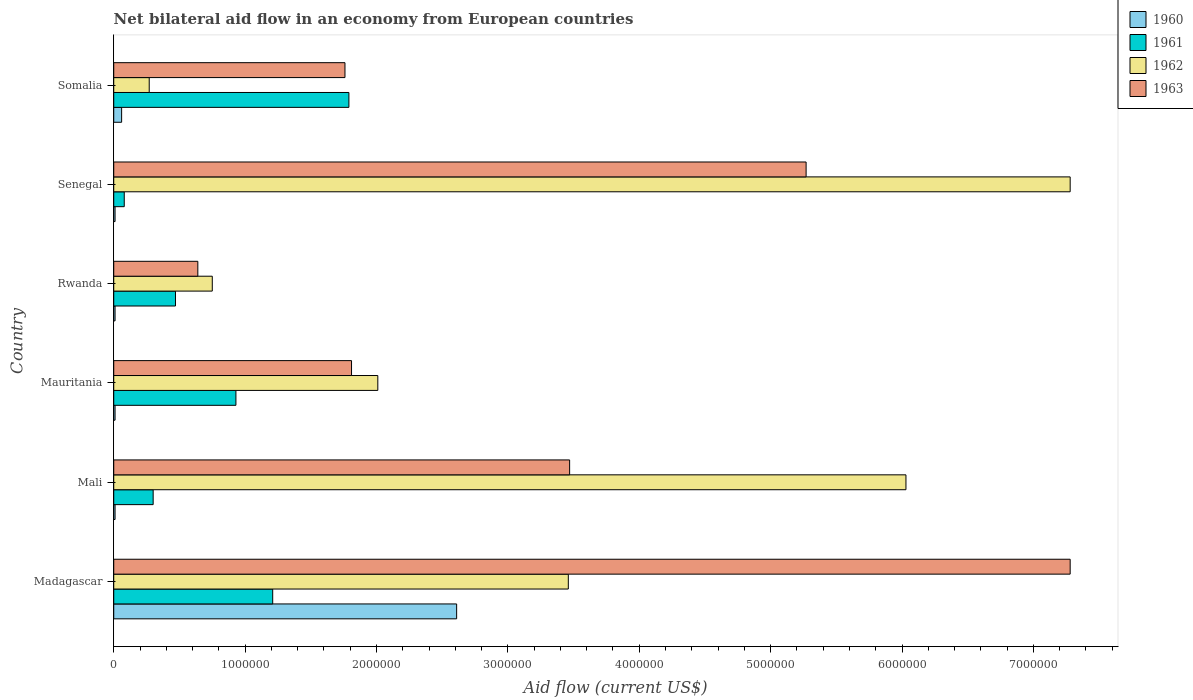How many groups of bars are there?
Provide a short and direct response. 6. Are the number of bars per tick equal to the number of legend labels?
Your response must be concise. Yes. How many bars are there on the 4th tick from the top?
Ensure brevity in your answer.  4. How many bars are there on the 3rd tick from the bottom?
Provide a succinct answer. 4. What is the label of the 1st group of bars from the top?
Your answer should be very brief. Somalia. What is the net bilateral aid flow in 1963 in Rwanda?
Keep it short and to the point. 6.40e+05. Across all countries, what is the maximum net bilateral aid flow in 1961?
Ensure brevity in your answer.  1.79e+06. Across all countries, what is the minimum net bilateral aid flow in 1961?
Provide a short and direct response. 8.00e+04. In which country was the net bilateral aid flow in 1963 maximum?
Your answer should be very brief. Madagascar. In which country was the net bilateral aid flow in 1962 minimum?
Give a very brief answer. Somalia. What is the total net bilateral aid flow in 1960 in the graph?
Offer a terse response. 2.71e+06. What is the difference between the net bilateral aid flow in 1961 in Mauritania and that in Senegal?
Your answer should be very brief. 8.50e+05. What is the average net bilateral aid flow in 1961 per country?
Ensure brevity in your answer.  7.97e+05. In how many countries, is the net bilateral aid flow in 1963 greater than 4400000 US$?
Provide a short and direct response. 2. What is the ratio of the net bilateral aid flow in 1960 in Madagascar to that in Mauritania?
Your response must be concise. 261. Is the net bilateral aid flow in 1963 in Mauritania less than that in Senegal?
Keep it short and to the point. Yes. Is the difference between the net bilateral aid flow in 1961 in Senegal and Somalia greater than the difference between the net bilateral aid flow in 1960 in Senegal and Somalia?
Offer a very short reply. No. What is the difference between the highest and the second highest net bilateral aid flow in 1961?
Provide a short and direct response. 5.80e+05. What is the difference between the highest and the lowest net bilateral aid flow in 1961?
Make the answer very short. 1.71e+06. Is the sum of the net bilateral aid flow in 1961 in Rwanda and Senegal greater than the maximum net bilateral aid flow in 1960 across all countries?
Keep it short and to the point. No. Is it the case that in every country, the sum of the net bilateral aid flow in 1963 and net bilateral aid flow in 1961 is greater than the sum of net bilateral aid flow in 1962 and net bilateral aid flow in 1960?
Give a very brief answer. Yes. What does the 3rd bar from the top in Madagascar represents?
Provide a short and direct response. 1961. What does the 1st bar from the bottom in Rwanda represents?
Your response must be concise. 1960. How many bars are there?
Make the answer very short. 24. What is the difference between two consecutive major ticks on the X-axis?
Your answer should be very brief. 1.00e+06. Are the values on the major ticks of X-axis written in scientific E-notation?
Offer a terse response. No. Does the graph contain grids?
Give a very brief answer. No. How many legend labels are there?
Give a very brief answer. 4. How are the legend labels stacked?
Ensure brevity in your answer.  Vertical. What is the title of the graph?
Keep it short and to the point. Net bilateral aid flow in an economy from European countries. What is the Aid flow (current US$) in 1960 in Madagascar?
Give a very brief answer. 2.61e+06. What is the Aid flow (current US$) of 1961 in Madagascar?
Keep it short and to the point. 1.21e+06. What is the Aid flow (current US$) in 1962 in Madagascar?
Make the answer very short. 3.46e+06. What is the Aid flow (current US$) in 1963 in Madagascar?
Your answer should be very brief. 7.28e+06. What is the Aid flow (current US$) of 1962 in Mali?
Ensure brevity in your answer.  6.03e+06. What is the Aid flow (current US$) in 1963 in Mali?
Provide a short and direct response. 3.47e+06. What is the Aid flow (current US$) in 1961 in Mauritania?
Your response must be concise. 9.30e+05. What is the Aid flow (current US$) in 1962 in Mauritania?
Give a very brief answer. 2.01e+06. What is the Aid flow (current US$) in 1963 in Mauritania?
Your response must be concise. 1.81e+06. What is the Aid flow (current US$) of 1962 in Rwanda?
Provide a succinct answer. 7.50e+05. What is the Aid flow (current US$) in 1963 in Rwanda?
Give a very brief answer. 6.40e+05. What is the Aid flow (current US$) of 1960 in Senegal?
Keep it short and to the point. 10000. What is the Aid flow (current US$) of 1962 in Senegal?
Give a very brief answer. 7.28e+06. What is the Aid flow (current US$) of 1963 in Senegal?
Make the answer very short. 5.27e+06. What is the Aid flow (current US$) in 1960 in Somalia?
Give a very brief answer. 6.00e+04. What is the Aid flow (current US$) in 1961 in Somalia?
Ensure brevity in your answer.  1.79e+06. What is the Aid flow (current US$) of 1962 in Somalia?
Your response must be concise. 2.70e+05. What is the Aid flow (current US$) of 1963 in Somalia?
Ensure brevity in your answer.  1.76e+06. Across all countries, what is the maximum Aid flow (current US$) of 1960?
Your answer should be very brief. 2.61e+06. Across all countries, what is the maximum Aid flow (current US$) in 1961?
Give a very brief answer. 1.79e+06. Across all countries, what is the maximum Aid flow (current US$) of 1962?
Provide a short and direct response. 7.28e+06. Across all countries, what is the maximum Aid flow (current US$) of 1963?
Give a very brief answer. 7.28e+06. Across all countries, what is the minimum Aid flow (current US$) in 1961?
Your answer should be very brief. 8.00e+04. Across all countries, what is the minimum Aid flow (current US$) of 1963?
Provide a short and direct response. 6.40e+05. What is the total Aid flow (current US$) of 1960 in the graph?
Provide a succinct answer. 2.71e+06. What is the total Aid flow (current US$) of 1961 in the graph?
Give a very brief answer. 4.78e+06. What is the total Aid flow (current US$) in 1962 in the graph?
Your answer should be very brief. 1.98e+07. What is the total Aid flow (current US$) in 1963 in the graph?
Provide a short and direct response. 2.02e+07. What is the difference between the Aid flow (current US$) in 1960 in Madagascar and that in Mali?
Give a very brief answer. 2.60e+06. What is the difference between the Aid flow (current US$) in 1961 in Madagascar and that in Mali?
Ensure brevity in your answer.  9.10e+05. What is the difference between the Aid flow (current US$) in 1962 in Madagascar and that in Mali?
Give a very brief answer. -2.57e+06. What is the difference between the Aid flow (current US$) in 1963 in Madagascar and that in Mali?
Your answer should be very brief. 3.81e+06. What is the difference between the Aid flow (current US$) of 1960 in Madagascar and that in Mauritania?
Your answer should be compact. 2.60e+06. What is the difference between the Aid flow (current US$) of 1961 in Madagascar and that in Mauritania?
Your answer should be very brief. 2.80e+05. What is the difference between the Aid flow (current US$) in 1962 in Madagascar and that in Mauritania?
Your answer should be very brief. 1.45e+06. What is the difference between the Aid flow (current US$) of 1963 in Madagascar and that in Mauritania?
Make the answer very short. 5.47e+06. What is the difference between the Aid flow (current US$) of 1960 in Madagascar and that in Rwanda?
Provide a short and direct response. 2.60e+06. What is the difference between the Aid flow (current US$) of 1961 in Madagascar and that in Rwanda?
Ensure brevity in your answer.  7.40e+05. What is the difference between the Aid flow (current US$) in 1962 in Madagascar and that in Rwanda?
Your answer should be very brief. 2.71e+06. What is the difference between the Aid flow (current US$) of 1963 in Madagascar and that in Rwanda?
Your answer should be very brief. 6.64e+06. What is the difference between the Aid flow (current US$) in 1960 in Madagascar and that in Senegal?
Offer a terse response. 2.60e+06. What is the difference between the Aid flow (current US$) in 1961 in Madagascar and that in Senegal?
Keep it short and to the point. 1.13e+06. What is the difference between the Aid flow (current US$) of 1962 in Madagascar and that in Senegal?
Your answer should be compact. -3.82e+06. What is the difference between the Aid flow (current US$) of 1963 in Madagascar and that in Senegal?
Provide a short and direct response. 2.01e+06. What is the difference between the Aid flow (current US$) of 1960 in Madagascar and that in Somalia?
Offer a terse response. 2.55e+06. What is the difference between the Aid flow (current US$) in 1961 in Madagascar and that in Somalia?
Give a very brief answer. -5.80e+05. What is the difference between the Aid flow (current US$) of 1962 in Madagascar and that in Somalia?
Keep it short and to the point. 3.19e+06. What is the difference between the Aid flow (current US$) in 1963 in Madagascar and that in Somalia?
Your answer should be very brief. 5.52e+06. What is the difference between the Aid flow (current US$) of 1960 in Mali and that in Mauritania?
Offer a terse response. 0. What is the difference between the Aid flow (current US$) in 1961 in Mali and that in Mauritania?
Offer a very short reply. -6.30e+05. What is the difference between the Aid flow (current US$) in 1962 in Mali and that in Mauritania?
Keep it short and to the point. 4.02e+06. What is the difference between the Aid flow (current US$) of 1963 in Mali and that in Mauritania?
Offer a very short reply. 1.66e+06. What is the difference between the Aid flow (current US$) of 1961 in Mali and that in Rwanda?
Ensure brevity in your answer.  -1.70e+05. What is the difference between the Aid flow (current US$) in 1962 in Mali and that in Rwanda?
Your response must be concise. 5.28e+06. What is the difference between the Aid flow (current US$) in 1963 in Mali and that in Rwanda?
Make the answer very short. 2.83e+06. What is the difference between the Aid flow (current US$) in 1960 in Mali and that in Senegal?
Your answer should be very brief. 0. What is the difference between the Aid flow (current US$) of 1962 in Mali and that in Senegal?
Ensure brevity in your answer.  -1.25e+06. What is the difference between the Aid flow (current US$) in 1963 in Mali and that in Senegal?
Provide a short and direct response. -1.80e+06. What is the difference between the Aid flow (current US$) of 1960 in Mali and that in Somalia?
Provide a short and direct response. -5.00e+04. What is the difference between the Aid flow (current US$) of 1961 in Mali and that in Somalia?
Keep it short and to the point. -1.49e+06. What is the difference between the Aid flow (current US$) of 1962 in Mali and that in Somalia?
Ensure brevity in your answer.  5.76e+06. What is the difference between the Aid flow (current US$) in 1963 in Mali and that in Somalia?
Make the answer very short. 1.71e+06. What is the difference between the Aid flow (current US$) of 1961 in Mauritania and that in Rwanda?
Make the answer very short. 4.60e+05. What is the difference between the Aid flow (current US$) in 1962 in Mauritania and that in Rwanda?
Make the answer very short. 1.26e+06. What is the difference between the Aid flow (current US$) in 1963 in Mauritania and that in Rwanda?
Your response must be concise. 1.17e+06. What is the difference between the Aid flow (current US$) of 1960 in Mauritania and that in Senegal?
Your response must be concise. 0. What is the difference between the Aid flow (current US$) in 1961 in Mauritania and that in Senegal?
Ensure brevity in your answer.  8.50e+05. What is the difference between the Aid flow (current US$) of 1962 in Mauritania and that in Senegal?
Keep it short and to the point. -5.27e+06. What is the difference between the Aid flow (current US$) of 1963 in Mauritania and that in Senegal?
Make the answer very short. -3.46e+06. What is the difference between the Aid flow (current US$) of 1960 in Mauritania and that in Somalia?
Your answer should be very brief. -5.00e+04. What is the difference between the Aid flow (current US$) of 1961 in Mauritania and that in Somalia?
Your response must be concise. -8.60e+05. What is the difference between the Aid flow (current US$) in 1962 in Mauritania and that in Somalia?
Give a very brief answer. 1.74e+06. What is the difference between the Aid flow (current US$) of 1963 in Mauritania and that in Somalia?
Give a very brief answer. 5.00e+04. What is the difference between the Aid flow (current US$) in 1960 in Rwanda and that in Senegal?
Offer a terse response. 0. What is the difference between the Aid flow (current US$) of 1961 in Rwanda and that in Senegal?
Provide a short and direct response. 3.90e+05. What is the difference between the Aid flow (current US$) of 1962 in Rwanda and that in Senegal?
Ensure brevity in your answer.  -6.53e+06. What is the difference between the Aid flow (current US$) of 1963 in Rwanda and that in Senegal?
Your answer should be compact. -4.63e+06. What is the difference between the Aid flow (current US$) of 1961 in Rwanda and that in Somalia?
Keep it short and to the point. -1.32e+06. What is the difference between the Aid flow (current US$) of 1963 in Rwanda and that in Somalia?
Your answer should be compact. -1.12e+06. What is the difference between the Aid flow (current US$) in 1961 in Senegal and that in Somalia?
Your answer should be very brief. -1.71e+06. What is the difference between the Aid flow (current US$) of 1962 in Senegal and that in Somalia?
Make the answer very short. 7.01e+06. What is the difference between the Aid flow (current US$) in 1963 in Senegal and that in Somalia?
Offer a very short reply. 3.51e+06. What is the difference between the Aid flow (current US$) in 1960 in Madagascar and the Aid flow (current US$) in 1961 in Mali?
Offer a very short reply. 2.31e+06. What is the difference between the Aid flow (current US$) in 1960 in Madagascar and the Aid flow (current US$) in 1962 in Mali?
Keep it short and to the point. -3.42e+06. What is the difference between the Aid flow (current US$) of 1960 in Madagascar and the Aid flow (current US$) of 1963 in Mali?
Make the answer very short. -8.60e+05. What is the difference between the Aid flow (current US$) of 1961 in Madagascar and the Aid flow (current US$) of 1962 in Mali?
Your answer should be very brief. -4.82e+06. What is the difference between the Aid flow (current US$) in 1961 in Madagascar and the Aid flow (current US$) in 1963 in Mali?
Keep it short and to the point. -2.26e+06. What is the difference between the Aid flow (current US$) in 1960 in Madagascar and the Aid flow (current US$) in 1961 in Mauritania?
Your answer should be compact. 1.68e+06. What is the difference between the Aid flow (current US$) of 1961 in Madagascar and the Aid flow (current US$) of 1962 in Mauritania?
Make the answer very short. -8.00e+05. What is the difference between the Aid flow (current US$) in 1961 in Madagascar and the Aid flow (current US$) in 1963 in Mauritania?
Make the answer very short. -6.00e+05. What is the difference between the Aid flow (current US$) of 1962 in Madagascar and the Aid flow (current US$) of 1963 in Mauritania?
Provide a short and direct response. 1.65e+06. What is the difference between the Aid flow (current US$) of 1960 in Madagascar and the Aid flow (current US$) of 1961 in Rwanda?
Offer a very short reply. 2.14e+06. What is the difference between the Aid flow (current US$) in 1960 in Madagascar and the Aid flow (current US$) in 1962 in Rwanda?
Your answer should be compact. 1.86e+06. What is the difference between the Aid flow (current US$) of 1960 in Madagascar and the Aid flow (current US$) of 1963 in Rwanda?
Your answer should be very brief. 1.97e+06. What is the difference between the Aid flow (current US$) in 1961 in Madagascar and the Aid flow (current US$) in 1963 in Rwanda?
Your response must be concise. 5.70e+05. What is the difference between the Aid flow (current US$) in 1962 in Madagascar and the Aid flow (current US$) in 1963 in Rwanda?
Keep it short and to the point. 2.82e+06. What is the difference between the Aid flow (current US$) in 1960 in Madagascar and the Aid flow (current US$) in 1961 in Senegal?
Keep it short and to the point. 2.53e+06. What is the difference between the Aid flow (current US$) of 1960 in Madagascar and the Aid flow (current US$) of 1962 in Senegal?
Keep it short and to the point. -4.67e+06. What is the difference between the Aid flow (current US$) in 1960 in Madagascar and the Aid flow (current US$) in 1963 in Senegal?
Provide a succinct answer. -2.66e+06. What is the difference between the Aid flow (current US$) in 1961 in Madagascar and the Aid flow (current US$) in 1962 in Senegal?
Your answer should be very brief. -6.07e+06. What is the difference between the Aid flow (current US$) of 1961 in Madagascar and the Aid flow (current US$) of 1963 in Senegal?
Provide a succinct answer. -4.06e+06. What is the difference between the Aid flow (current US$) in 1962 in Madagascar and the Aid flow (current US$) in 1963 in Senegal?
Give a very brief answer. -1.81e+06. What is the difference between the Aid flow (current US$) in 1960 in Madagascar and the Aid flow (current US$) in 1961 in Somalia?
Keep it short and to the point. 8.20e+05. What is the difference between the Aid flow (current US$) in 1960 in Madagascar and the Aid flow (current US$) in 1962 in Somalia?
Give a very brief answer. 2.34e+06. What is the difference between the Aid flow (current US$) in 1960 in Madagascar and the Aid flow (current US$) in 1963 in Somalia?
Offer a terse response. 8.50e+05. What is the difference between the Aid flow (current US$) in 1961 in Madagascar and the Aid flow (current US$) in 1962 in Somalia?
Your response must be concise. 9.40e+05. What is the difference between the Aid flow (current US$) in 1961 in Madagascar and the Aid flow (current US$) in 1963 in Somalia?
Ensure brevity in your answer.  -5.50e+05. What is the difference between the Aid flow (current US$) in 1962 in Madagascar and the Aid flow (current US$) in 1963 in Somalia?
Make the answer very short. 1.70e+06. What is the difference between the Aid flow (current US$) of 1960 in Mali and the Aid flow (current US$) of 1961 in Mauritania?
Ensure brevity in your answer.  -9.20e+05. What is the difference between the Aid flow (current US$) in 1960 in Mali and the Aid flow (current US$) in 1962 in Mauritania?
Ensure brevity in your answer.  -2.00e+06. What is the difference between the Aid flow (current US$) in 1960 in Mali and the Aid flow (current US$) in 1963 in Mauritania?
Give a very brief answer. -1.80e+06. What is the difference between the Aid flow (current US$) in 1961 in Mali and the Aid flow (current US$) in 1962 in Mauritania?
Provide a short and direct response. -1.71e+06. What is the difference between the Aid flow (current US$) in 1961 in Mali and the Aid flow (current US$) in 1963 in Mauritania?
Make the answer very short. -1.51e+06. What is the difference between the Aid flow (current US$) of 1962 in Mali and the Aid flow (current US$) of 1963 in Mauritania?
Your answer should be compact. 4.22e+06. What is the difference between the Aid flow (current US$) of 1960 in Mali and the Aid flow (current US$) of 1961 in Rwanda?
Provide a succinct answer. -4.60e+05. What is the difference between the Aid flow (current US$) of 1960 in Mali and the Aid flow (current US$) of 1962 in Rwanda?
Your answer should be compact. -7.40e+05. What is the difference between the Aid flow (current US$) in 1960 in Mali and the Aid flow (current US$) in 1963 in Rwanda?
Ensure brevity in your answer.  -6.30e+05. What is the difference between the Aid flow (current US$) of 1961 in Mali and the Aid flow (current US$) of 1962 in Rwanda?
Offer a terse response. -4.50e+05. What is the difference between the Aid flow (current US$) of 1961 in Mali and the Aid flow (current US$) of 1963 in Rwanda?
Your response must be concise. -3.40e+05. What is the difference between the Aid flow (current US$) of 1962 in Mali and the Aid flow (current US$) of 1963 in Rwanda?
Offer a terse response. 5.39e+06. What is the difference between the Aid flow (current US$) of 1960 in Mali and the Aid flow (current US$) of 1961 in Senegal?
Your answer should be very brief. -7.00e+04. What is the difference between the Aid flow (current US$) of 1960 in Mali and the Aid flow (current US$) of 1962 in Senegal?
Your response must be concise. -7.27e+06. What is the difference between the Aid flow (current US$) of 1960 in Mali and the Aid flow (current US$) of 1963 in Senegal?
Provide a succinct answer. -5.26e+06. What is the difference between the Aid flow (current US$) in 1961 in Mali and the Aid flow (current US$) in 1962 in Senegal?
Your response must be concise. -6.98e+06. What is the difference between the Aid flow (current US$) in 1961 in Mali and the Aid flow (current US$) in 1963 in Senegal?
Give a very brief answer. -4.97e+06. What is the difference between the Aid flow (current US$) in 1962 in Mali and the Aid flow (current US$) in 1963 in Senegal?
Provide a succinct answer. 7.60e+05. What is the difference between the Aid flow (current US$) of 1960 in Mali and the Aid flow (current US$) of 1961 in Somalia?
Make the answer very short. -1.78e+06. What is the difference between the Aid flow (current US$) in 1960 in Mali and the Aid flow (current US$) in 1963 in Somalia?
Your answer should be compact. -1.75e+06. What is the difference between the Aid flow (current US$) in 1961 in Mali and the Aid flow (current US$) in 1962 in Somalia?
Your response must be concise. 3.00e+04. What is the difference between the Aid flow (current US$) in 1961 in Mali and the Aid flow (current US$) in 1963 in Somalia?
Offer a terse response. -1.46e+06. What is the difference between the Aid flow (current US$) in 1962 in Mali and the Aid flow (current US$) in 1963 in Somalia?
Your answer should be compact. 4.27e+06. What is the difference between the Aid flow (current US$) of 1960 in Mauritania and the Aid flow (current US$) of 1961 in Rwanda?
Offer a very short reply. -4.60e+05. What is the difference between the Aid flow (current US$) of 1960 in Mauritania and the Aid flow (current US$) of 1962 in Rwanda?
Keep it short and to the point. -7.40e+05. What is the difference between the Aid flow (current US$) of 1960 in Mauritania and the Aid flow (current US$) of 1963 in Rwanda?
Provide a short and direct response. -6.30e+05. What is the difference between the Aid flow (current US$) in 1962 in Mauritania and the Aid flow (current US$) in 1963 in Rwanda?
Offer a terse response. 1.37e+06. What is the difference between the Aid flow (current US$) of 1960 in Mauritania and the Aid flow (current US$) of 1962 in Senegal?
Provide a succinct answer. -7.27e+06. What is the difference between the Aid flow (current US$) of 1960 in Mauritania and the Aid flow (current US$) of 1963 in Senegal?
Offer a terse response. -5.26e+06. What is the difference between the Aid flow (current US$) of 1961 in Mauritania and the Aid flow (current US$) of 1962 in Senegal?
Offer a very short reply. -6.35e+06. What is the difference between the Aid flow (current US$) in 1961 in Mauritania and the Aid flow (current US$) in 1963 in Senegal?
Your answer should be compact. -4.34e+06. What is the difference between the Aid flow (current US$) of 1962 in Mauritania and the Aid flow (current US$) of 1963 in Senegal?
Make the answer very short. -3.26e+06. What is the difference between the Aid flow (current US$) of 1960 in Mauritania and the Aid flow (current US$) of 1961 in Somalia?
Your answer should be compact. -1.78e+06. What is the difference between the Aid flow (current US$) of 1960 in Mauritania and the Aid flow (current US$) of 1963 in Somalia?
Offer a terse response. -1.75e+06. What is the difference between the Aid flow (current US$) of 1961 in Mauritania and the Aid flow (current US$) of 1962 in Somalia?
Your response must be concise. 6.60e+05. What is the difference between the Aid flow (current US$) in 1961 in Mauritania and the Aid flow (current US$) in 1963 in Somalia?
Ensure brevity in your answer.  -8.30e+05. What is the difference between the Aid flow (current US$) in 1962 in Mauritania and the Aid flow (current US$) in 1963 in Somalia?
Your answer should be very brief. 2.50e+05. What is the difference between the Aid flow (current US$) of 1960 in Rwanda and the Aid flow (current US$) of 1961 in Senegal?
Provide a succinct answer. -7.00e+04. What is the difference between the Aid flow (current US$) in 1960 in Rwanda and the Aid flow (current US$) in 1962 in Senegal?
Offer a terse response. -7.27e+06. What is the difference between the Aid flow (current US$) of 1960 in Rwanda and the Aid flow (current US$) of 1963 in Senegal?
Your response must be concise. -5.26e+06. What is the difference between the Aid flow (current US$) of 1961 in Rwanda and the Aid flow (current US$) of 1962 in Senegal?
Ensure brevity in your answer.  -6.81e+06. What is the difference between the Aid flow (current US$) in 1961 in Rwanda and the Aid flow (current US$) in 1963 in Senegal?
Ensure brevity in your answer.  -4.80e+06. What is the difference between the Aid flow (current US$) in 1962 in Rwanda and the Aid flow (current US$) in 1963 in Senegal?
Make the answer very short. -4.52e+06. What is the difference between the Aid flow (current US$) in 1960 in Rwanda and the Aid flow (current US$) in 1961 in Somalia?
Provide a succinct answer. -1.78e+06. What is the difference between the Aid flow (current US$) of 1960 in Rwanda and the Aid flow (current US$) of 1963 in Somalia?
Your answer should be compact. -1.75e+06. What is the difference between the Aid flow (current US$) of 1961 in Rwanda and the Aid flow (current US$) of 1963 in Somalia?
Provide a succinct answer. -1.29e+06. What is the difference between the Aid flow (current US$) of 1962 in Rwanda and the Aid flow (current US$) of 1963 in Somalia?
Your response must be concise. -1.01e+06. What is the difference between the Aid flow (current US$) of 1960 in Senegal and the Aid flow (current US$) of 1961 in Somalia?
Your response must be concise. -1.78e+06. What is the difference between the Aid flow (current US$) in 1960 in Senegal and the Aid flow (current US$) in 1963 in Somalia?
Your answer should be very brief. -1.75e+06. What is the difference between the Aid flow (current US$) in 1961 in Senegal and the Aid flow (current US$) in 1963 in Somalia?
Provide a short and direct response. -1.68e+06. What is the difference between the Aid flow (current US$) in 1962 in Senegal and the Aid flow (current US$) in 1963 in Somalia?
Keep it short and to the point. 5.52e+06. What is the average Aid flow (current US$) in 1960 per country?
Offer a terse response. 4.52e+05. What is the average Aid flow (current US$) of 1961 per country?
Provide a succinct answer. 7.97e+05. What is the average Aid flow (current US$) in 1962 per country?
Provide a succinct answer. 3.30e+06. What is the average Aid flow (current US$) in 1963 per country?
Provide a succinct answer. 3.37e+06. What is the difference between the Aid flow (current US$) of 1960 and Aid flow (current US$) of 1961 in Madagascar?
Your response must be concise. 1.40e+06. What is the difference between the Aid flow (current US$) in 1960 and Aid flow (current US$) in 1962 in Madagascar?
Offer a terse response. -8.50e+05. What is the difference between the Aid flow (current US$) of 1960 and Aid flow (current US$) of 1963 in Madagascar?
Your response must be concise. -4.67e+06. What is the difference between the Aid flow (current US$) in 1961 and Aid flow (current US$) in 1962 in Madagascar?
Offer a very short reply. -2.25e+06. What is the difference between the Aid flow (current US$) in 1961 and Aid flow (current US$) in 1963 in Madagascar?
Give a very brief answer. -6.07e+06. What is the difference between the Aid flow (current US$) in 1962 and Aid flow (current US$) in 1963 in Madagascar?
Provide a short and direct response. -3.82e+06. What is the difference between the Aid flow (current US$) in 1960 and Aid flow (current US$) in 1961 in Mali?
Your response must be concise. -2.90e+05. What is the difference between the Aid flow (current US$) of 1960 and Aid flow (current US$) of 1962 in Mali?
Keep it short and to the point. -6.02e+06. What is the difference between the Aid flow (current US$) in 1960 and Aid flow (current US$) in 1963 in Mali?
Make the answer very short. -3.46e+06. What is the difference between the Aid flow (current US$) in 1961 and Aid flow (current US$) in 1962 in Mali?
Offer a very short reply. -5.73e+06. What is the difference between the Aid flow (current US$) in 1961 and Aid flow (current US$) in 1963 in Mali?
Keep it short and to the point. -3.17e+06. What is the difference between the Aid flow (current US$) of 1962 and Aid flow (current US$) of 1963 in Mali?
Make the answer very short. 2.56e+06. What is the difference between the Aid flow (current US$) in 1960 and Aid flow (current US$) in 1961 in Mauritania?
Your response must be concise. -9.20e+05. What is the difference between the Aid flow (current US$) of 1960 and Aid flow (current US$) of 1962 in Mauritania?
Keep it short and to the point. -2.00e+06. What is the difference between the Aid flow (current US$) in 1960 and Aid flow (current US$) in 1963 in Mauritania?
Offer a very short reply. -1.80e+06. What is the difference between the Aid flow (current US$) of 1961 and Aid flow (current US$) of 1962 in Mauritania?
Your answer should be very brief. -1.08e+06. What is the difference between the Aid flow (current US$) of 1961 and Aid flow (current US$) of 1963 in Mauritania?
Offer a terse response. -8.80e+05. What is the difference between the Aid flow (current US$) in 1960 and Aid flow (current US$) in 1961 in Rwanda?
Provide a short and direct response. -4.60e+05. What is the difference between the Aid flow (current US$) in 1960 and Aid flow (current US$) in 1962 in Rwanda?
Offer a terse response. -7.40e+05. What is the difference between the Aid flow (current US$) in 1960 and Aid flow (current US$) in 1963 in Rwanda?
Offer a very short reply. -6.30e+05. What is the difference between the Aid flow (current US$) in 1961 and Aid flow (current US$) in 1962 in Rwanda?
Keep it short and to the point. -2.80e+05. What is the difference between the Aid flow (current US$) of 1961 and Aid flow (current US$) of 1963 in Rwanda?
Keep it short and to the point. -1.70e+05. What is the difference between the Aid flow (current US$) in 1962 and Aid flow (current US$) in 1963 in Rwanda?
Your answer should be very brief. 1.10e+05. What is the difference between the Aid flow (current US$) of 1960 and Aid flow (current US$) of 1961 in Senegal?
Your answer should be very brief. -7.00e+04. What is the difference between the Aid flow (current US$) in 1960 and Aid flow (current US$) in 1962 in Senegal?
Keep it short and to the point. -7.27e+06. What is the difference between the Aid flow (current US$) in 1960 and Aid flow (current US$) in 1963 in Senegal?
Your response must be concise. -5.26e+06. What is the difference between the Aid flow (current US$) of 1961 and Aid flow (current US$) of 1962 in Senegal?
Offer a very short reply. -7.20e+06. What is the difference between the Aid flow (current US$) in 1961 and Aid flow (current US$) in 1963 in Senegal?
Offer a very short reply. -5.19e+06. What is the difference between the Aid flow (current US$) of 1962 and Aid flow (current US$) of 1963 in Senegal?
Offer a very short reply. 2.01e+06. What is the difference between the Aid flow (current US$) in 1960 and Aid flow (current US$) in 1961 in Somalia?
Offer a very short reply. -1.73e+06. What is the difference between the Aid flow (current US$) in 1960 and Aid flow (current US$) in 1963 in Somalia?
Your answer should be very brief. -1.70e+06. What is the difference between the Aid flow (current US$) of 1961 and Aid flow (current US$) of 1962 in Somalia?
Give a very brief answer. 1.52e+06. What is the difference between the Aid flow (current US$) in 1961 and Aid flow (current US$) in 1963 in Somalia?
Give a very brief answer. 3.00e+04. What is the difference between the Aid flow (current US$) of 1962 and Aid flow (current US$) of 1963 in Somalia?
Give a very brief answer. -1.49e+06. What is the ratio of the Aid flow (current US$) of 1960 in Madagascar to that in Mali?
Make the answer very short. 261. What is the ratio of the Aid flow (current US$) of 1961 in Madagascar to that in Mali?
Offer a terse response. 4.03. What is the ratio of the Aid flow (current US$) in 1962 in Madagascar to that in Mali?
Give a very brief answer. 0.57. What is the ratio of the Aid flow (current US$) in 1963 in Madagascar to that in Mali?
Ensure brevity in your answer.  2.1. What is the ratio of the Aid flow (current US$) of 1960 in Madagascar to that in Mauritania?
Keep it short and to the point. 261. What is the ratio of the Aid flow (current US$) in 1961 in Madagascar to that in Mauritania?
Your answer should be compact. 1.3. What is the ratio of the Aid flow (current US$) of 1962 in Madagascar to that in Mauritania?
Your response must be concise. 1.72. What is the ratio of the Aid flow (current US$) of 1963 in Madagascar to that in Mauritania?
Offer a terse response. 4.02. What is the ratio of the Aid flow (current US$) in 1960 in Madagascar to that in Rwanda?
Provide a succinct answer. 261. What is the ratio of the Aid flow (current US$) of 1961 in Madagascar to that in Rwanda?
Offer a very short reply. 2.57. What is the ratio of the Aid flow (current US$) in 1962 in Madagascar to that in Rwanda?
Make the answer very short. 4.61. What is the ratio of the Aid flow (current US$) in 1963 in Madagascar to that in Rwanda?
Your answer should be very brief. 11.38. What is the ratio of the Aid flow (current US$) of 1960 in Madagascar to that in Senegal?
Keep it short and to the point. 261. What is the ratio of the Aid flow (current US$) in 1961 in Madagascar to that in Senegal?
Provide a short and direct response. 15.12. What is the ratio of the Aid flow (current US$) of 1962 in Madagascar to that in Senegal?
Keep it short and to the point. 0.48. What is the ratio of the Aid flow (current US$) of 1963 in Madagascar to that in Senegal?
Make the answer very short. 1.38. What is the ratio of the Aid flow (current US$) in 1960 in Madagascar to that in Somalia?
Make the answer very short. 43.5. What is the ratio of the Aid flow (current US$) in 1961 in Madagascar to that in Somalia?
Offer a terse response. 0.68. What is the ratio of the Aid flow (current US$) in 1962 in Madagascar to that in Somalia?
Your answer should be compact. 12.81. What is the ratio of the Aid flow (current US$) of 1963 in Madagascar to that in Somalia?
Give a very brief answer. 4.14. What is the ratio of the Aid flow (current US$) in 1961 in Mali to that in Mauritania?
Make the answer very short. 0.32. What is the ratio of the Aid flow (current US$) of 1962 in Mali to that in Mauritania?
Offer a terse response. 3. What is the ratio of the Aid flow (current US$) in 1963 in Mali to that in Mauritania?
Your answer should be compact. 1.92. What is the ratio of the Aid flow (current US$) of 1960 in Mali to that in Rwanda?
Offer a very short reply. 1. What is the ratio of the Aid flow (current US$) in 1961 in Mali to that in Rwanda?
Give a very brief answer. 0.64. What is the ratio of the Aid flow (current US$) of 1962 in Mali to that in Rwanda?
Give a very brief answer. 8.04. What is the ratio of the Aid flow (current US$) in 1963 in Mali to that in Rwanda?
Offer a terse response. 5.42. What is the ratio of the Aid flow (current US$) of 1961 in Mali to that in Senegal?
Your answer should be compact. 3.75. What is the ratio of the Aid flow (current US$) of 1962 in Mali to that in Senegal?
Offer a very short reply. 0.83. What is the ratio of the Aid flow (current US$) of 1963 in Mali to that in Senegal?
Offer a very short reply. 0.66. What is the ratio of the Aid flow (current US$) in 1960 in Mali to that in Somalia?
Make the answer very short. 0.17. What is the ratio of the Aid flow (current US$) in 1961 in Mali to that in Somalia?
Your answer should be very brief. 0.17. What is the ratio of the Aid flow (current US$) in 1962 in Mali to that in Somalia?
Make the answer very short. 22.33. What is the ratio of the Aid flow (current US$) in 1963 in Mali to that in Somalia?
Offer a very short reply. 1.97. What is the ratio of the Aid flow (current US$) in 1960 in Mauritania to that in Rwanda?
Ensure brevity in your answer.  1. What is the ratio of the Aid flow (current US$) of 1961 in Mauritania to that in Rwanda?
Make the answer very short. 1.98. What is the ratio of the Aid flow (current US$) in 1962 in Mauritania to that in Rwanda?
Offer a terse response. 2.68. What is the ratio of the Aid flow (current US$) of 1963 in Mauritania to that in Rwanda?
Offer a terse response. 2.83. What is the ratio of the Aid flow (current US$) in 1961 in Mauritania to that in Senegal?
Provide a short and direct response. 11.62. What is the ratio of the Aid flow (current US$) of 1962 in Mauritania to that in Senegal?
Ensure brevity in your answer.  0.28. What is the ratio of the Aid flow (current US$) of 1963 in Mauritania to that in Senegal?
Keep it short and to the point. 0.34. What is the ratio of the Aid flow (current US$) of 1960 in Mauritania to that in Somalia?
Offer a very short reply. 0.17. What is the ratio of the Aid flow (current US$) in 1961 in Mauritania to that in Somalia?
Your answer should be very brief. 0.52. What is the ratio of the Aid flow (current US$) in 1962 in Mauritania to that in Somalia?
Your answer should be very brief. 7.44. What is the ratio of the Aid flow (current US$) in 1963 in Mauritania to that in Somalia?
Offer a terse response. 1.03. What is the ratio of the Aid flow (current US$) of 1960 in Rwanda to that in Senegal?
Keep it short and to the point. 1. What is the ratio of the Aid flow (current US$) of 1961 in Rwanda to that in Senegal?
Your answer should be compact. 5.88. What is the ratio of the Aid flow (current US$) of 1962 in Rwanda to that in Senegal?
Offer a very short reply. 0.1. What is the ratio of the Aid flow (current US$) in 1963 in Rwanda to that in Senegal?
Offer a terse response. 0.12. What is the ratio of the Aid flow (current US$) of 1960 in Rwanda to that in Somalia?
Your response must be concise. 0.17. What is the ratio of the Aid flow (current US$) in 1961 in Rwanda to that in Somalia?
Your answer should be compact. 0.26. What is the ratio of the Aid flow (current US$) in 1962 in Rwanda to that in Somalia?
Make the answer very short. 2.78. What is the ratio of the Aid flow (current US$) of 1963 in Rwanda to that in Somalia?
Provide a short and direct response. 0.36. What is the ratio of the Aid flow (current US$) in 1960 in Senegal to that in Somalia?
Provide a succinct answer. 0.17. What is the ratio of the Aid flow (current US$) of 1961 in Senegal to that in Somalia?
Offer a terse response. 0.04. What is the ratio of the Aid flow (current US$) of 1962 in Senegal to that in Somalia?
Make the answer very short. 26.96. What is the ratio of the Aid flow (current US$) in 1963 in Senegal to that in Somalia?
Ensure brevity in your answer.  2.99. What is the difference between the highest and the second highest Aid flow (current US$) in 1960?
Offer a very short reply. 2.55e+06. What is the difference between the highest and the second highest Aid flow (current US$) of 1961?
Provide a short and direct response. 5.80e+05. What is the difference between the highest and the second highest Aid flow (current US$) of 1962?
Keep it short and to the point. 1.25e+06. What is the difference between the highest and the second highest Aid flow (current US$) of 1963?
Your answer should be compact. 2.01e+06. What is the difference between the highest and the lowest Aid flow (current US$) in 1960?
Provide a short and direct response. 2.60e+06. What is the difference between the highest and the lowest Aid flow (current US$) in 1961?
Offer a very short reply. 1.71e+06. What is the difference between the highest and the lowest Aid flow (current US$) of 1962?
Make the answer very short. 7.01e+06. What is the difference between the highest and the lowest Aid flow (current US$) in 1963?
Your answer should be very brief. 6.64e+06. 